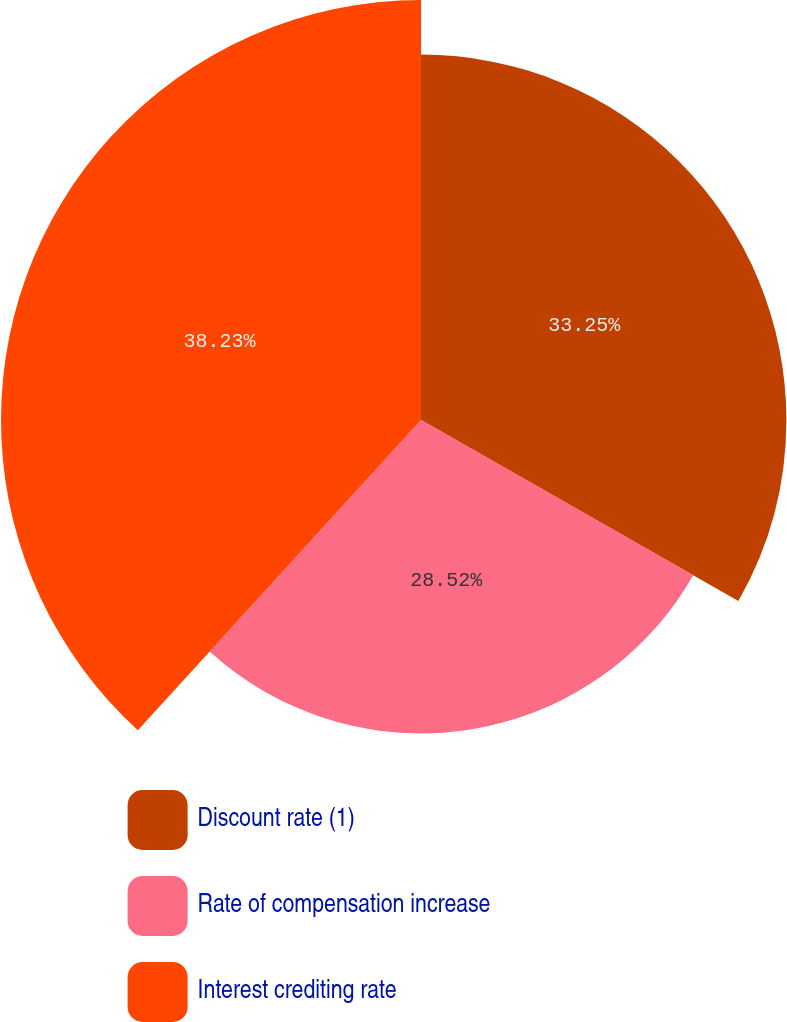Convert chart. <chart><loc_0><loc_0><loc_500><loc_500><pie_chart><fcel>Discount rate (1)<fcel>Rate of compensation increase<fcel>Interest crediting rate<nl><fcel>33.25%<fcel>28.52%<fcel>38.22%<nl></chart> 